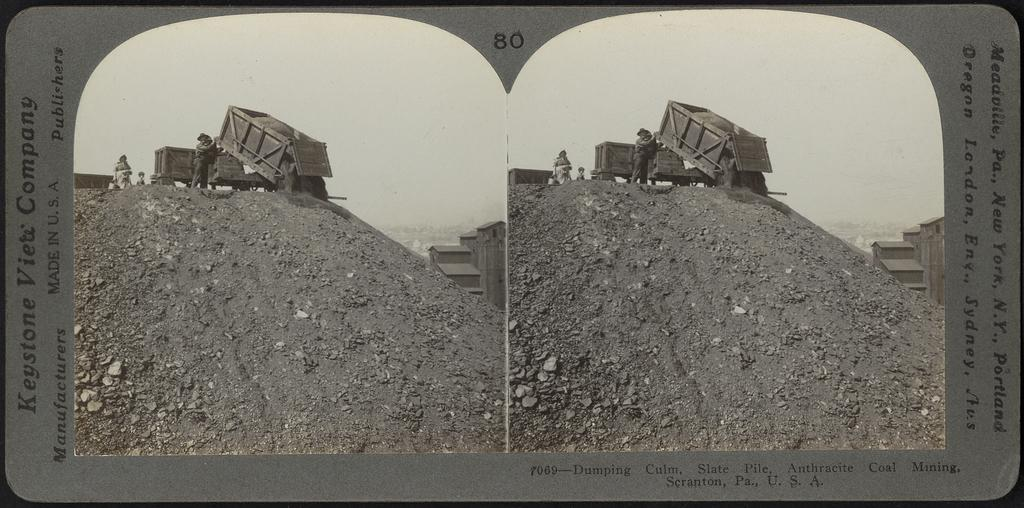<image>
Create a compact narrative representing the image presented. Keystone company picture of a dump truck showing a the truck at work. 